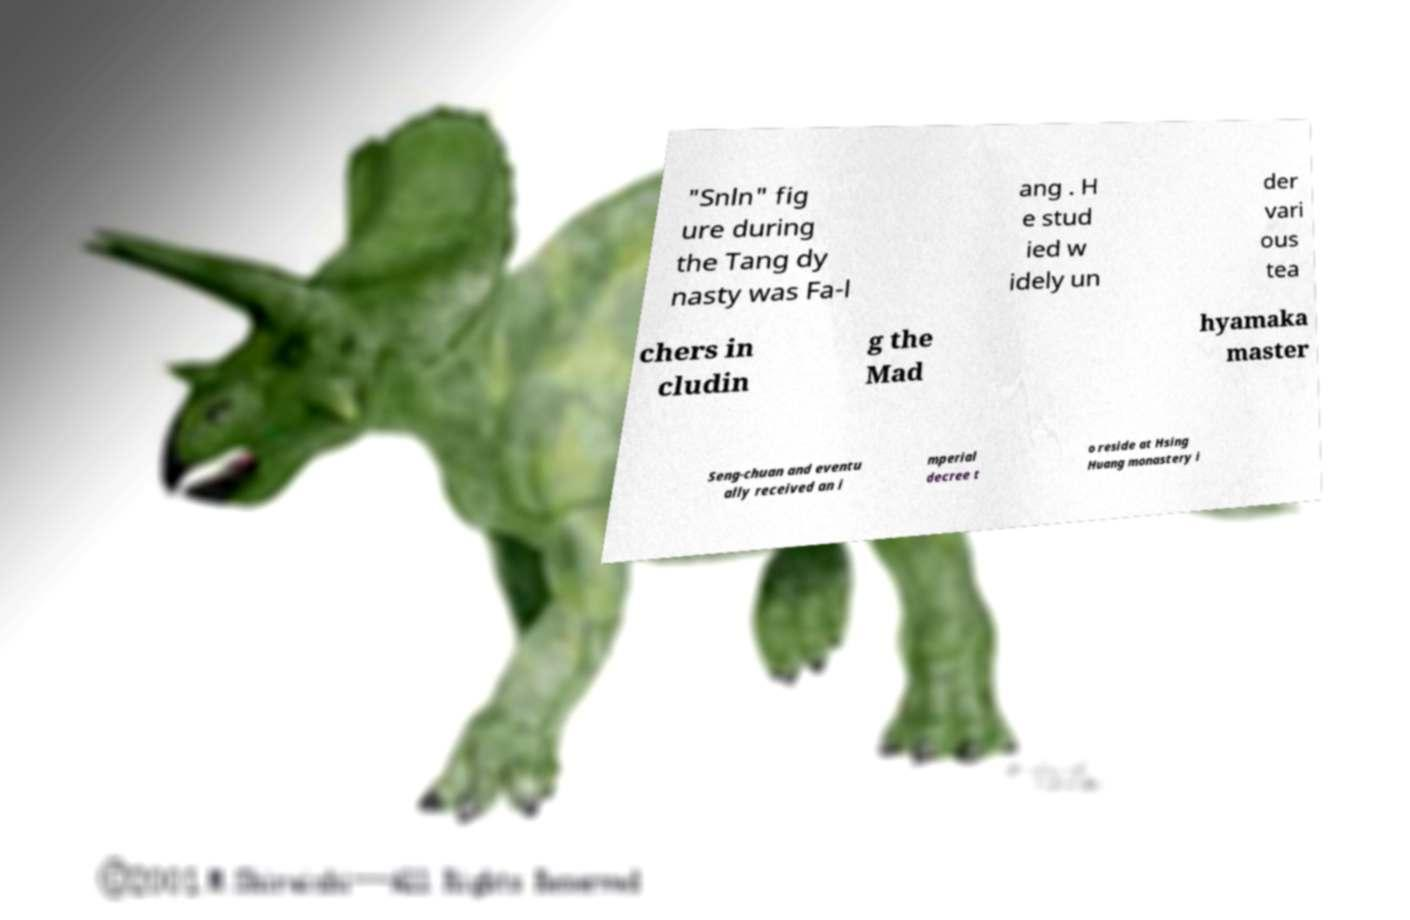For documentation purposes, I need the text within this image transcribed. Could you provide that? "Snln" fig ure during the Tang dy nasty was Fa-l ang . H e stud ied w idely un der vari ous tea chers in cludin g the Mad hyamaka master Seng-chuan and eventu ally received an i mperial decree t o reside at Hsing Huang monastery i 